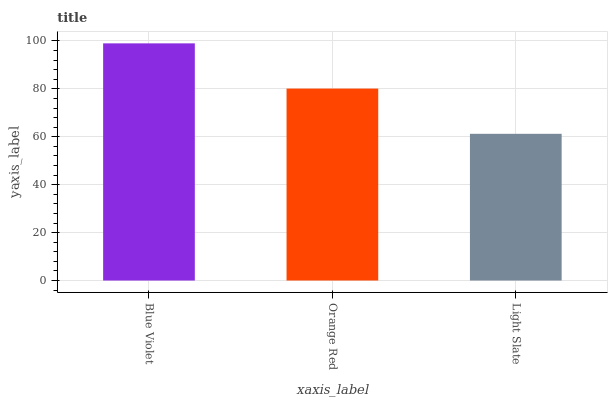Is Light Slate the minimum?
Answer yes or no. Yes. Is Blue Violet the maximum?
Answer yes or no. Yes. Is Orange Red the minimum?
Answer yes or no. No. Is Orange Red the maximum?
Answer yes or no. No. Is Blue Violet greater than Orange Red?
Answer yes or no. Yes. Is Orange Red less than Blue Violet?
Answer yes or no. Yes. Is Orange Red greater than Blue Violet?
Answer yes or no. No. Is Blue Violet less than Orange Red?
Answer yes or no. No. Is Orange Red the high median?
Answer yes or no. Yes. Is Orange Red the low median?
Answer yes or no. Yes. Is Blue Violet the high median?
Answer yes or no. No. Is Light Slate the low median?
Answer yes or no. No. 